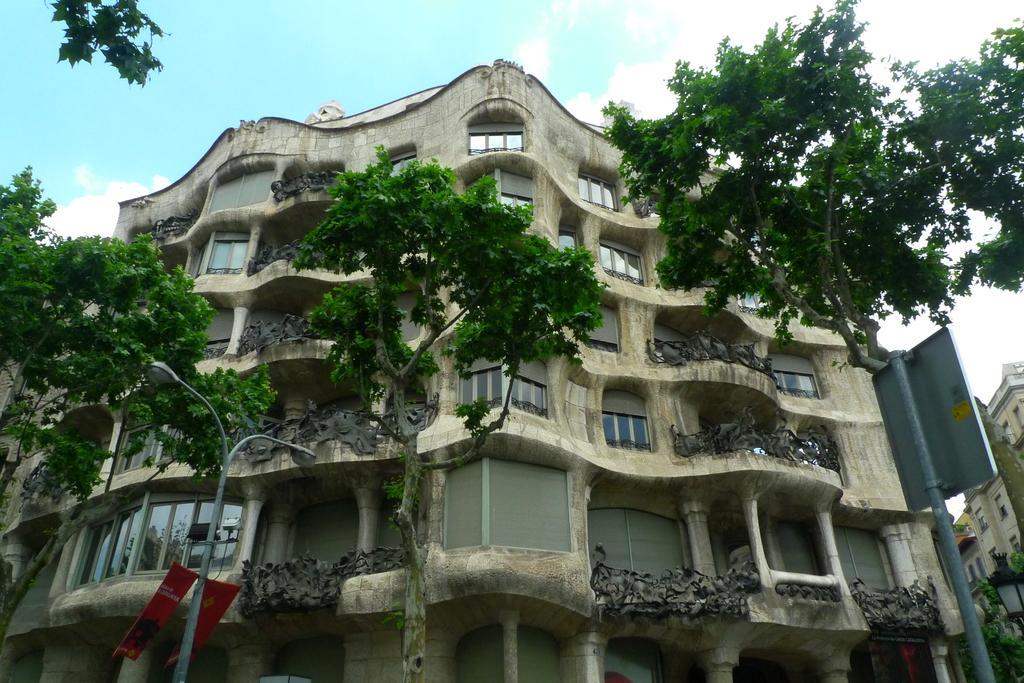In one or two sentences, can you explain what this image depicts? There are trees and poles. There are buildings at the back. 